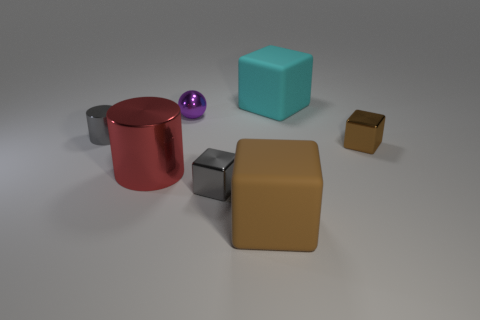Subtract all gray cubes. How many cubes are left? 3 Subtract all spheres. How many objects are left? 6 Add 1 big green rubber blocks. How many objects exist? 8 Subtract all red blocks. How many red cylinders are left? 1 Subtract all big brown shiny objects. Subtract all large shiny objects. How many objects are left? 6 Add 5 big rubber things. How many big rubber things are left? 7 Add 3 tiny gray shiny things. How many tiny gray shiny things exist? 5 Subtract 0 blue spheres. How many objects are left? 7 Subtract 3 blocks. How many blocks are left? 1 Subtract all yellow blocks. Subtract all yellow balls. How many blocks are left? 4 